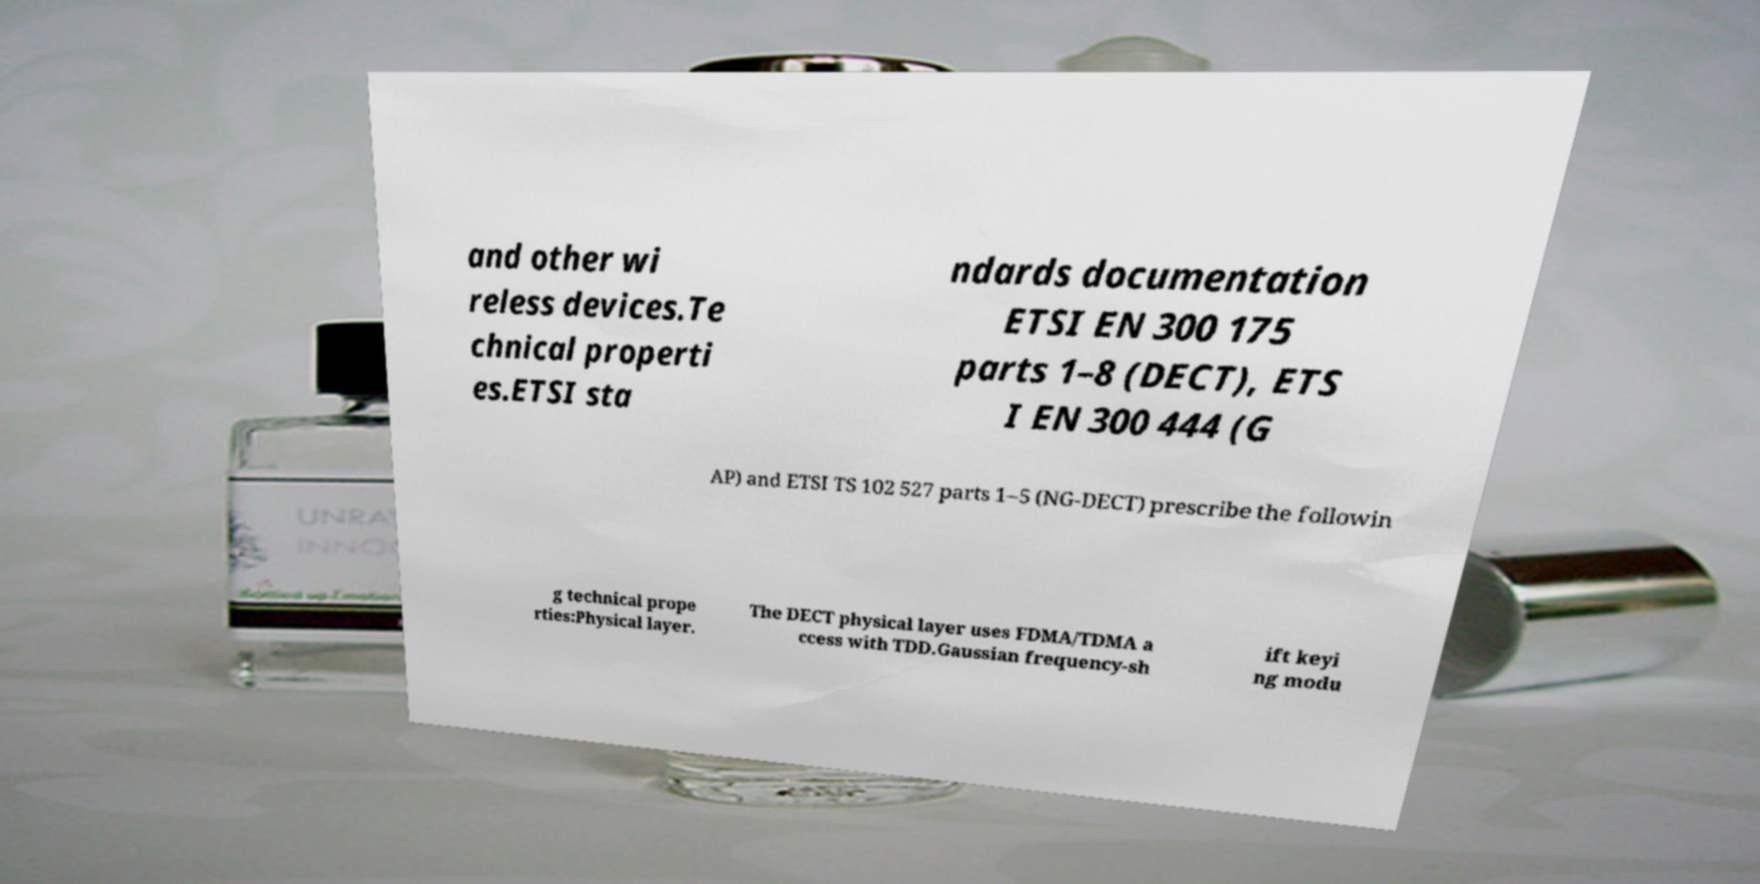Could you assist in decoding the text presented in this image and type it out clearly? and other wi reless devices.Te chnical properti es.ETSI sta ndards documentation ETSI EN 300 175 parts 1–8 (DECT), ETS I EN 300 444 (G AP) and ETSI TS 102 527 parts 1–5 (NG-DECT) prescribe the followin g technical prope rties:Physical layer. The DECT physical layer uses FDMA/TDMA a ccess with TDD.Gaussian frequency-sh ift keyi ng modu 